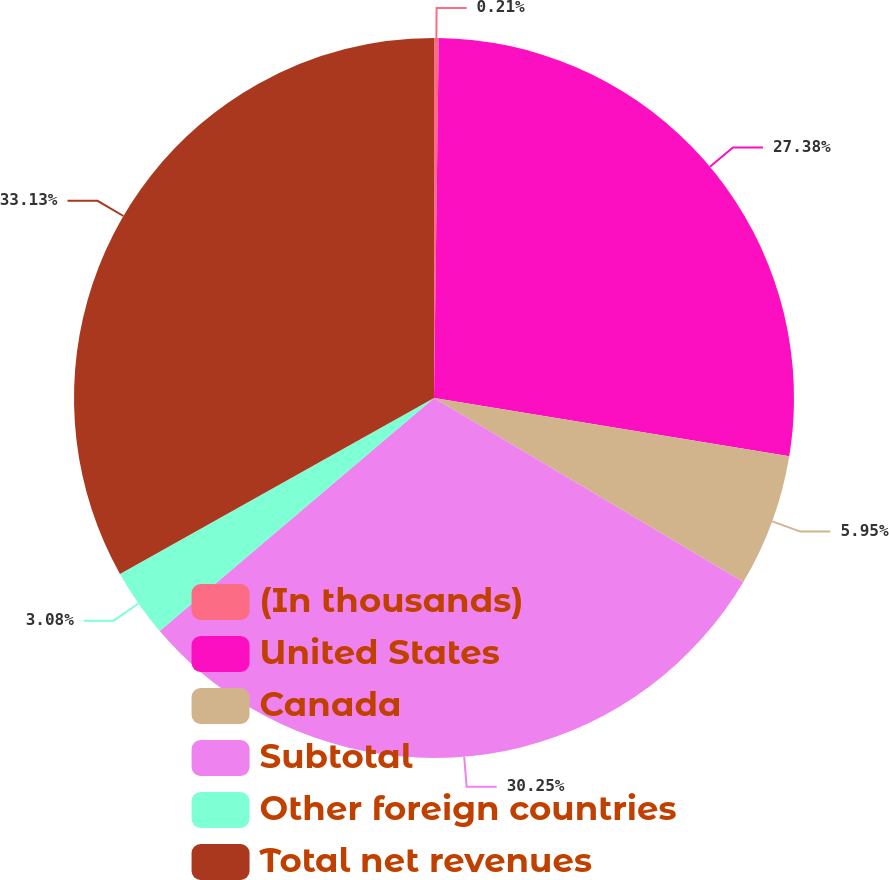<chart> <loc_0><loc_0><loc_500><loc_500><pie_chart><fcel>(In thousands)<fcel>United States<fcel>Canada<fcel>Subtotal<fcel>Other foreign countries<fcel>Total net revenues<nl><fcel>0.21%<fcel>27.38%<fcel>5.95%<fcel>30.25%<fcel>3.08%<fcel>33.13%<nl></chart> 